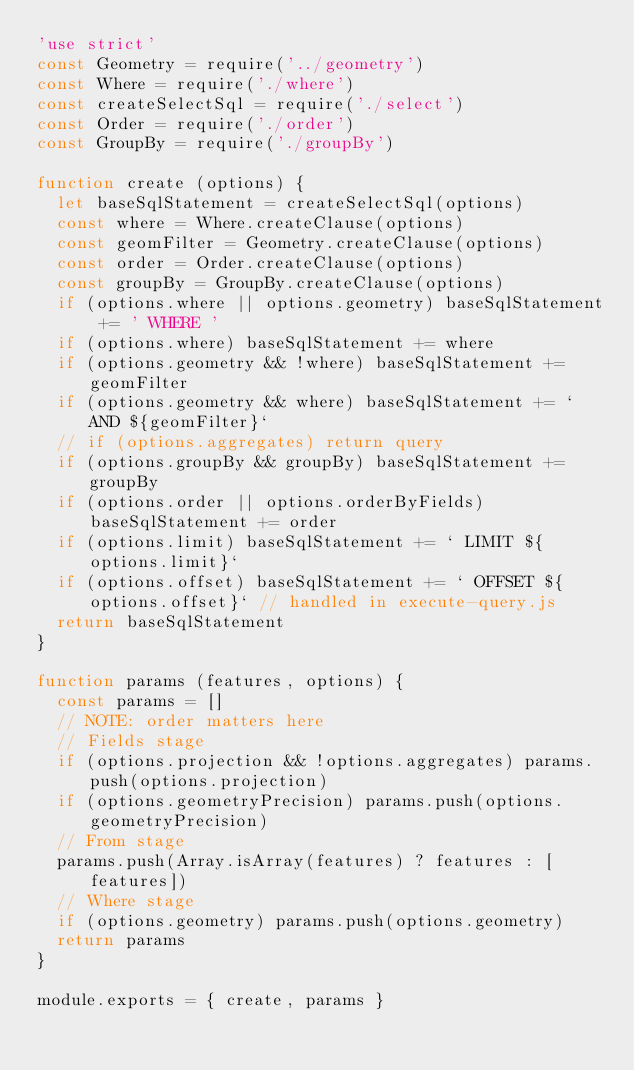<code> <loc_0><loc_0><loc_500><loc_500><_JavaScript_>'use strict'
const Geometry = require('../geometry')
const Where = require('./where')
const createSelectSql = require('./select')
const Order = require('./order')
const GroupBy = require('./groupBy')

function create (options) {
  let baseSqlStatement = createSelectSql(options)
  const where = Where.createClause(options)
  const geomFilter = Geometry.createClause(options)
  const order = Order.createClause(options)
  const groupBy = GroupBy.createClause(options)
  if (options.where || options.geometry) baseSqlStatement += ' WHERE '
  if (options.where) baseSqlStatement += where
  if (options.geometry && !where) baseSqlStatement += geomFilter
  if (options.geometry && where) baseSqlStatement += ` AND ${geomFilter}`
  // if (options.aggregates) return query
  if (options.groupBy && groupBy) baseSqlStatement += groupBy
  if (options.order || options.orderByFields) baseSqlStatement += order
  if (options.limit) baseSqlStatement += ` LIMIT ${options.limit}`
  if (options.offset) baseSqlStatement += ` OFFSET ${options.offset}` // handled in execute-query.js
  return baseSqlStatement
}

function params (features, options) {
  const params = []
  // NOTE: order matters here
  // Fields stage
  if (options.projection && !options.aggregates) params.push(options.projection)
  if (options.geometryPrecision) params.push(options.geometryPrecision)
  // From stage
  params.push(Array.isArray(features) ? features : [features])
  // Where stage
  if (options.geometry) params.push(options.geometry)
  return params
}

module.exports = { create, params }
</code> 